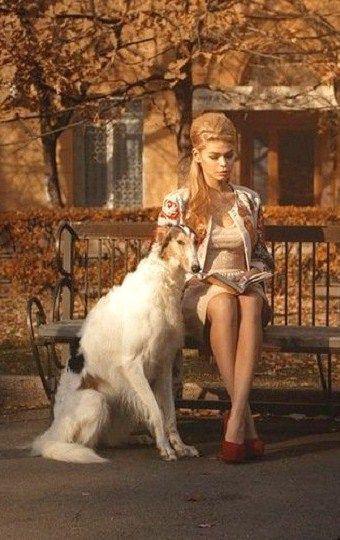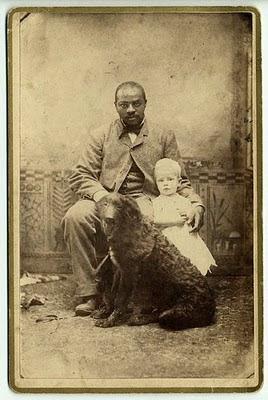The first image is the image on the left, the second image is the image on the right. Given the left and right images, does the statement "There is a woman sitting down with a dog next to her." hold true? Answer yes or no. Yes. The first image is the image on the left, the second image is the image on the right. Given the left and right images, does the statement "In at least one image there is a single female in a dress sit in a chair next to her white dog." hold true? Answer yes or no. Yes. 